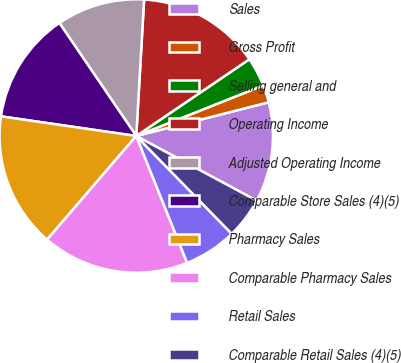<chart> <loc_0><loc_0><loc_500><loc_500><pie_chart><fcel>Sales<fcel>Gross Profit<fcel>Selling general and<fcel>Operating Income<fcel>Adjusted Operating Income<fcel>Comparable Store Sales (4)(5)<fcel>Pharmacy Sales<fcel>Comparable Pharmacy Sales<fcel>Retail Sales<fcel>Comparable Retail Sales (4)(5)<nl><fcel>11.81%<fcel>2.06%<fcel>3.46%<fcel>14.6%<fcel>10.42%<fcel>13.2%<fcel>15.99%<fcel>17.38%<fcel>6.24%<fcel>4.85%<nl></chart> 